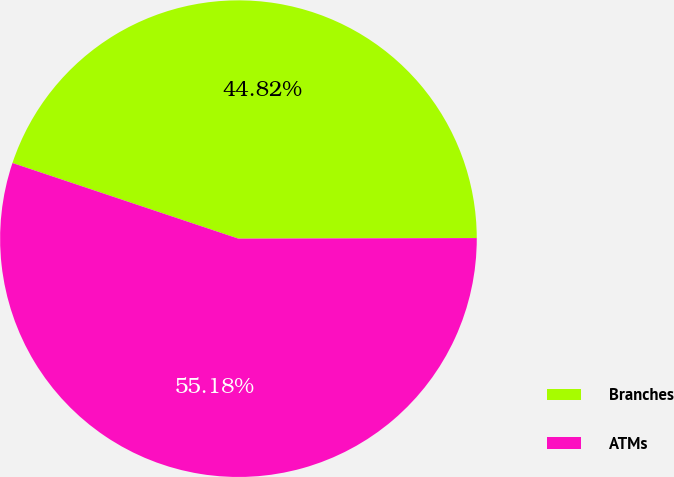<chart> <loc_0><loc_0><loc_500><loc_500><pie_chart><fcel>Branches<fcel>ATMs<nl><fcel>44.82%<fcel>55.18%<nl></chart> 